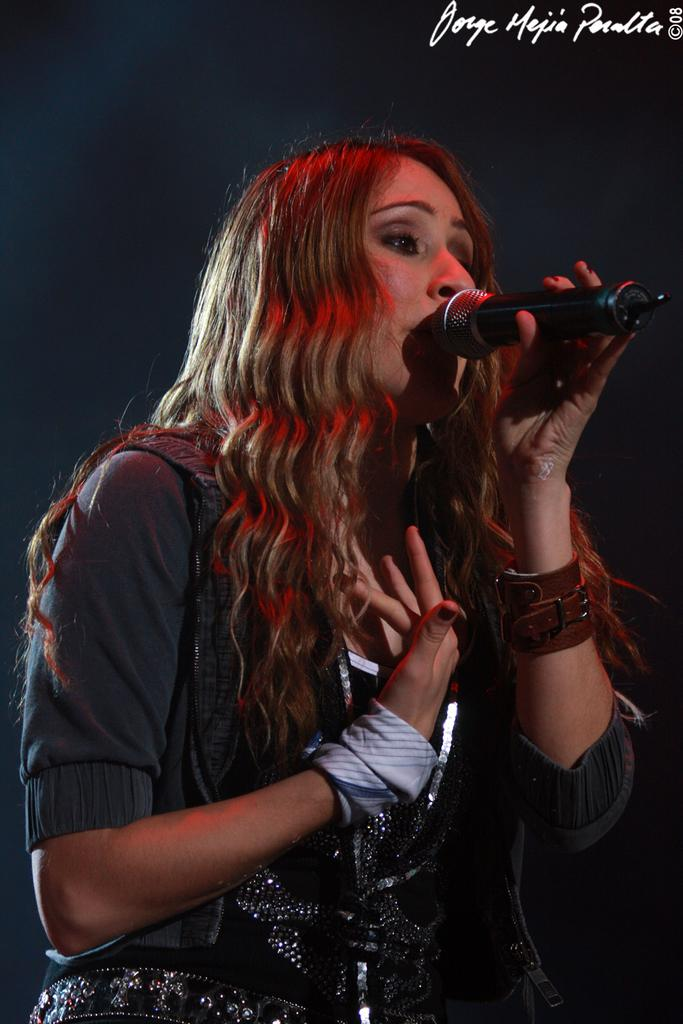Who is the main subject in the image? There is a woman in the image. What is the woman holding in the image? The woman is holding a microphone. What is the woman doing in the image? The woman is singing. What type of apple can be seen on the woman's head in the image? There is no apple present on the woman's head in the image. What sound can be heard coming from the microphone in the image? The image is static, so no sound can be heard from the microphone. 